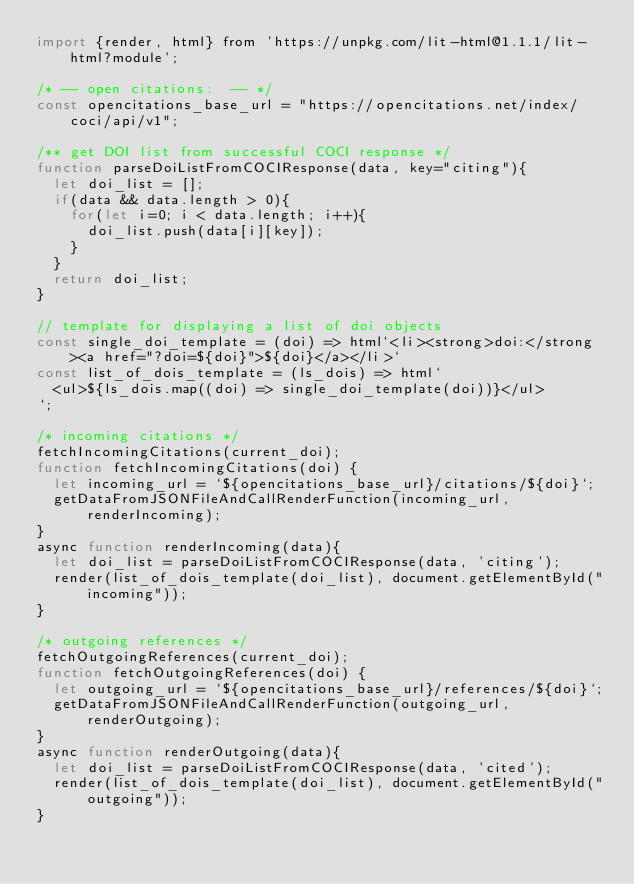<code> <loc_0><loc_0><loc_500><loc_500><_JavaScript_>import {render, html} from 'https://unpkg.com/lit-html@1.1.1/lit-html?module';

/* -- open citations:  -- */
const opencitations_base_url = "https://opencitations.net/index/coci/api/v1";

/** get DOI list from successful COCI response */
function parseDoiListFromCOCIResponse(data, key="citing"){
  let doi_list = [];
  if(data && data.length > 0){
    for(let i=0; i < data.length; i++){
      doi_list.push(data[i][key]);
    }
  }
  return doi_list;
}

// template for displaying a list of doi objects
const single_doi_template = (doi) => html`<li><strong>doi:</strong><a href="?doi=${doi}">${doi}</a></li>`
const list_of_dois_template = (ls_dois) => html`
  <ul>${ls_dois.map((doi) => single_doi_template(doi))}</ul>
`;

/* incoming citations */ 
fetchIncomingCitations(current_doi);
function fetchIncomingCitations(doi) {
  let incoming_url = `${opencitations_base_url}/citations/${doi}`;
  getDataFromJSONFileAndCallRenderFunction(incoming_url, renderIncoming);
}
async function renderIncoming(data){
  let doi_list = parseDoiListFromCOCIResponse(data, 'citing');
  render(list_of_dois_template(doi_list), document.getElementById("incoming"));
}

/* outgoing references */
fetchOutgoingReferences(current_doi);
function fetchOutgoingReferences(doi) {
  let outgoing_url = `${opencitations_base_url}/references/${doi}`;
  getDataFromJSONFileAndCallRenderFunction(outgoing_url, renderOutgoing);
}
async function renderOutgoing(data){
  let doi_list = parseDoiListFromCOCIResponse(data, 'cited');
  render(list_of_dois_template(doi_list), document.getElementById("outgoing"));
}</code> 